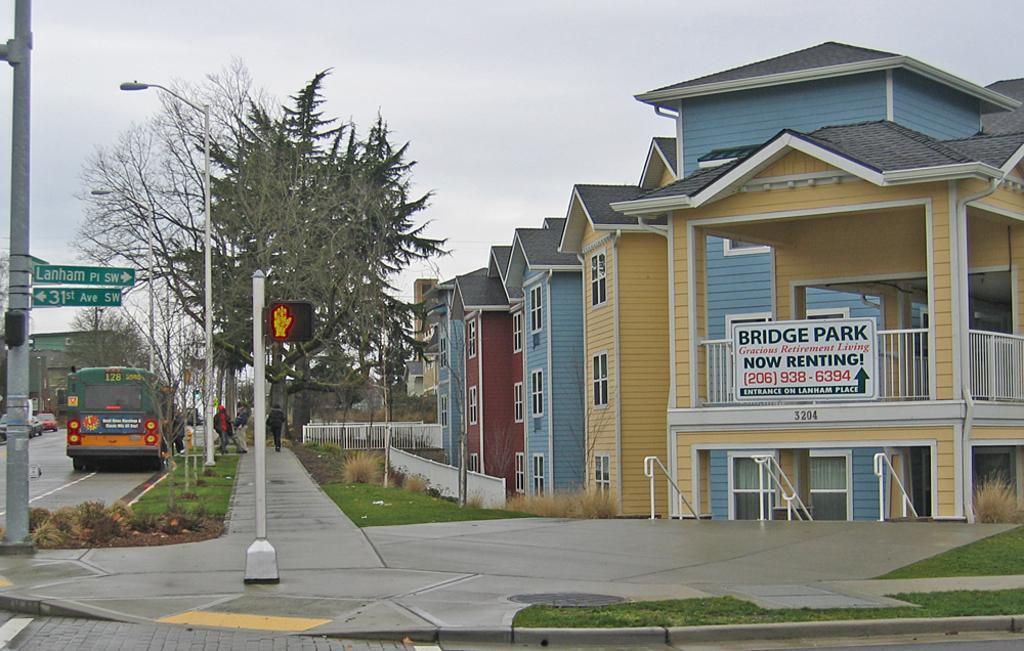Could you give a brief overview of what you see in this image? In this image we can see the buildings look like houses. And we can see the vehicles on the road. And we can see the people. And we can see the street lights. And we can see the sign boards. And we can see the grass. And we can see the metal fencing. And we can see the sky. And we can see the poles. 